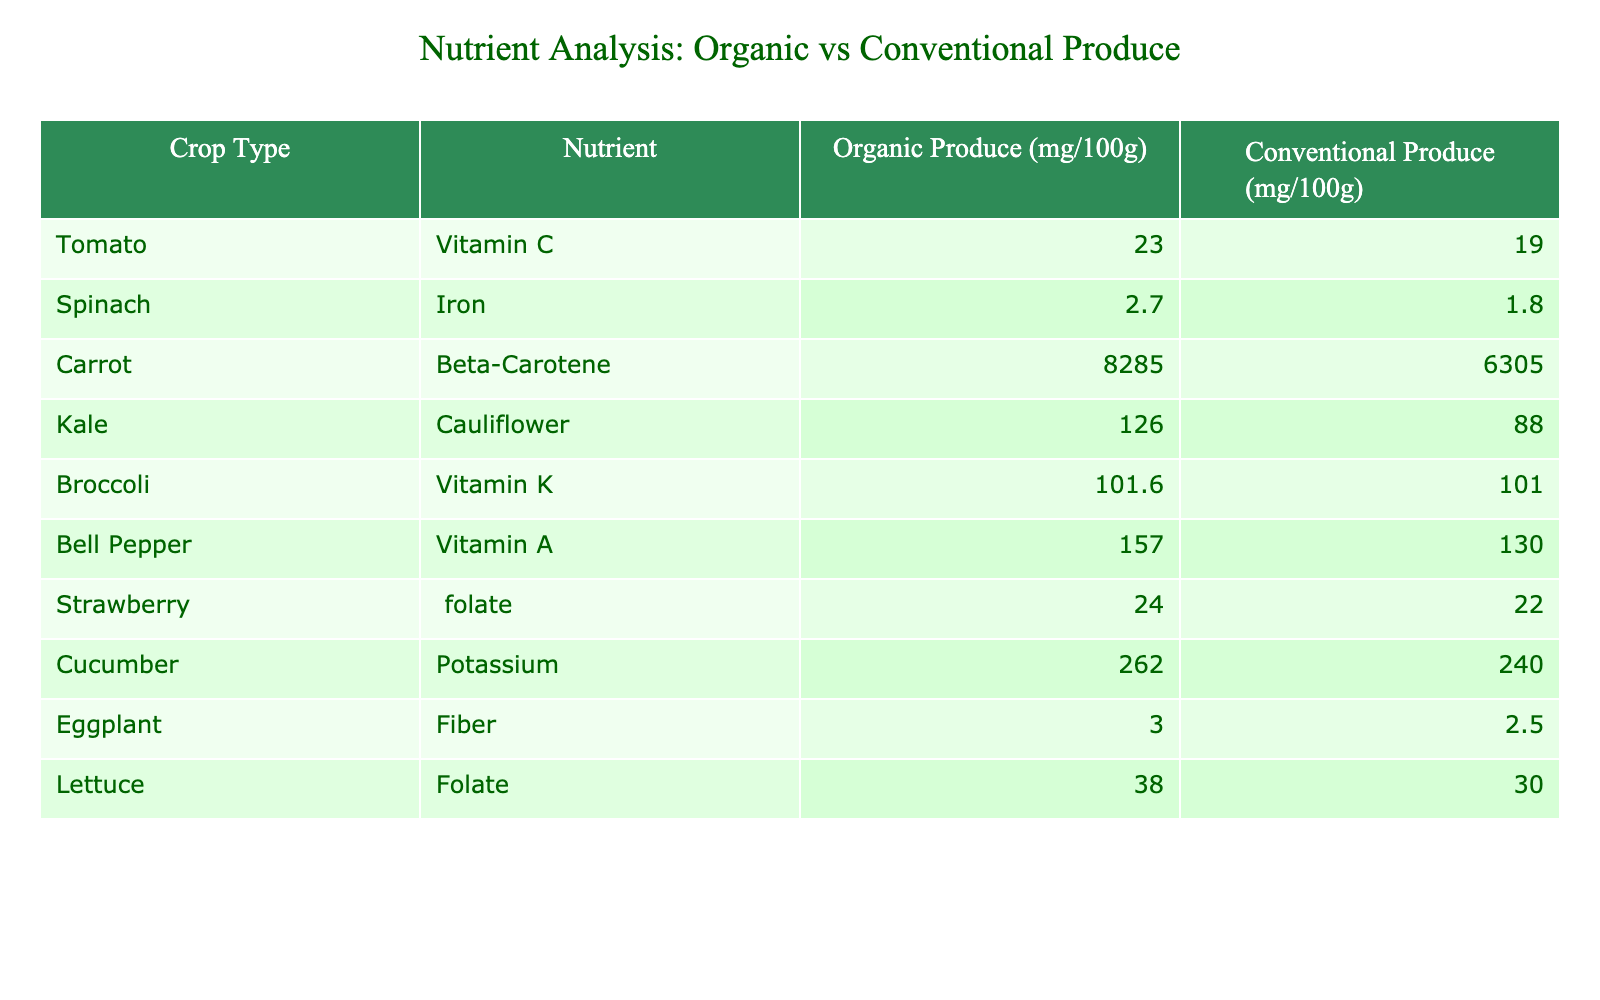What is the Vitamin C content in organic tomatoes? The table shows the nutrient content for different crops. Looking at the row for tomatoes under the "Organic Produce" column, the Vitamin C content is listed as 23.0 mg/100g.
Answer: 23.0 mg/100g Which crop has the highest Beta-Carotene content? The table lists Beta-Carotene content for carrots under the "Organic Produce" column as 8285 mg/100g, while all other crops either have lower values or do not have Beta-Carotene listed. Thus, carrots have the highest Beta-Carotene content.
Answer: Carrot Is the Iron content in organic spinach higher than in conventional spinach? By comparing the Iron content under the "Organic Produce" column for spinach (2.7 mg/100g) and under the "Conventional Produce" column (1.8 mg/100g), it is clear that the organic spinach has a higher Iron content compared to conventional spinach.
Answer: Yes What is the difference in Folate content between organic and conventional strawberries? The table indicates that organic strawberries contain 24 mg/100g and conventional strawberries contain 22 mg/100g. To find the difference, we subtract the conventional value from the organic value: 24 - 22 = 2 mg/100g.
Answer: 2 mg/100g Which crop has more Potassium, organic or conventional? For cucumbers, the organic Potassium content is shown as 262 mg/100g, and the conventional Potassium content is 240 mg/100g. Comparing these values, organic cucumbers have a higher Potassium content than conventional cucumbers.
Answer: Organic has more Potassium 